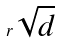<formula> <loc_0><loc_0><loc_500><loc_500>r \sqrt { d }</formula> 